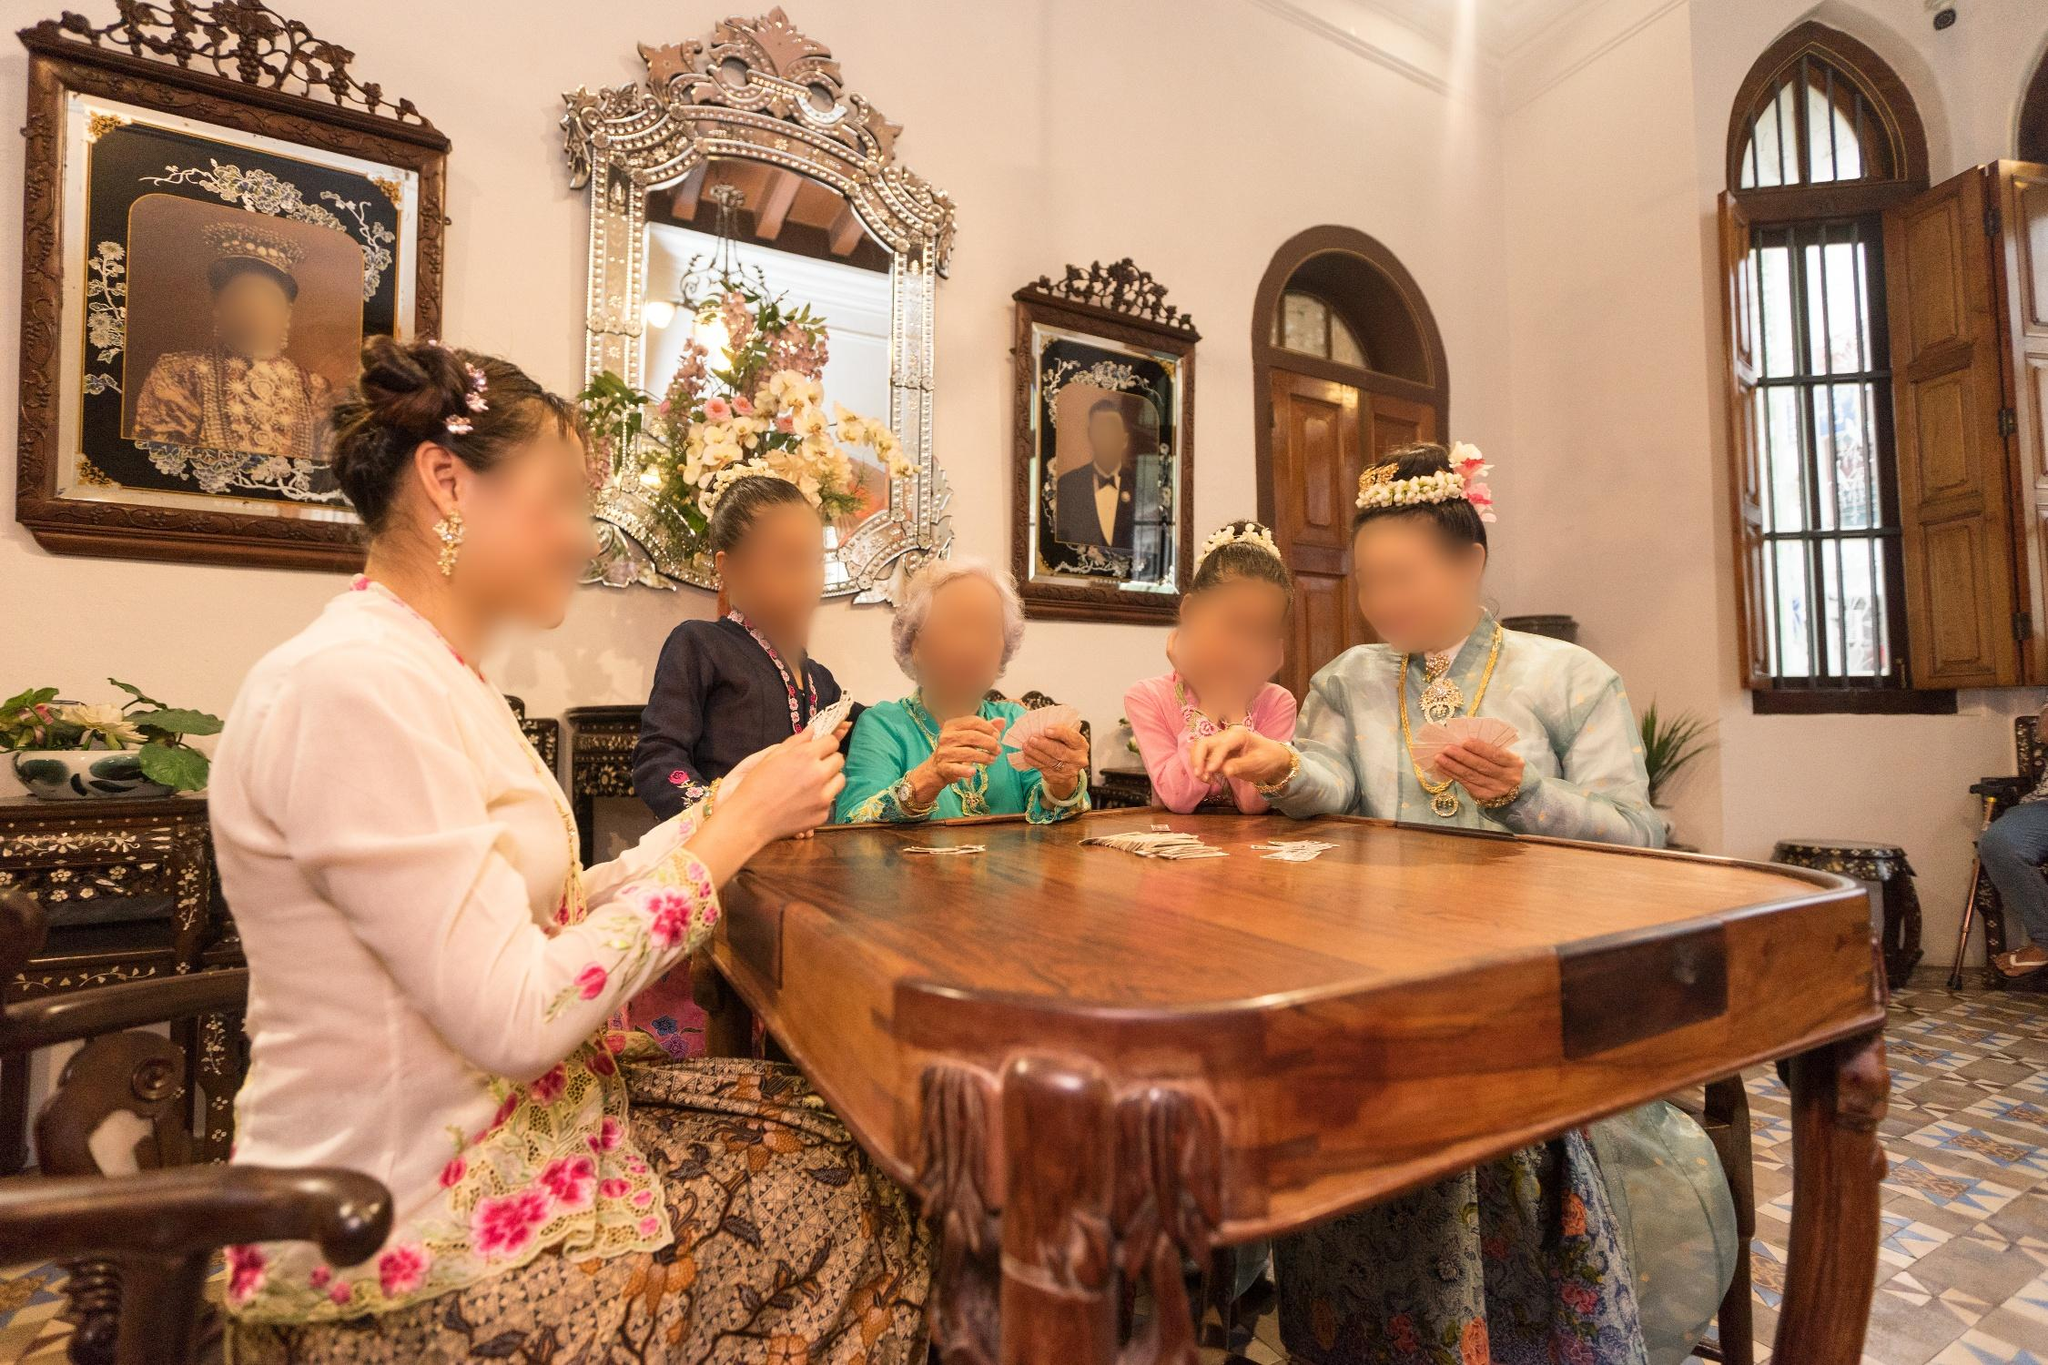Explain the visual content of the image in great detail.
 The image captures a lively scene in a room that seems to be steeped in history. A group of people, adorned in traditional clothing with vibrant floral patterns and unique headpieces, are gathered around a dark wooden table. The room itself is quite ornate, featuring arched windows that hint at the building's historic architecture. The high ceiling adds to the grandeur of the space. 

The walls are decorated with several framed paintings and a mirror, reflecting the room's rich aesthetics. The perspective of the image is from the side of the table, providing a view that encompasses both the people and the room's decorations. The overall atmosphere is one of camaraderie and tradition, as if the people are engaged in a significant cultural event. 

As for the landmark identification "sa_12621", I couldn't find specific information related to this code in my current knowledge base. It might be an internal code or identifier used by a specific organization or system. If you have more context or details about this code, I might be able to provide a more accurate response. 